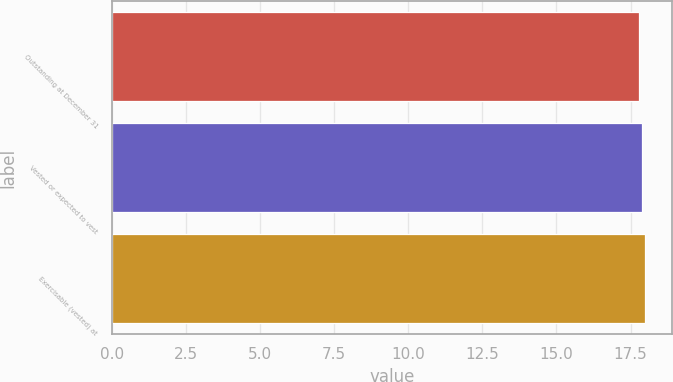<chart> <loc_0><loc_0><loc_500><loc_500><bar_chart><fcel>Outstanding at December 31<fcel>Vested or expected to vest<fcel>Exercisable (vested) at<nl><fcel>17.8<fcel>17.9<fcel>18<nl></chart> 